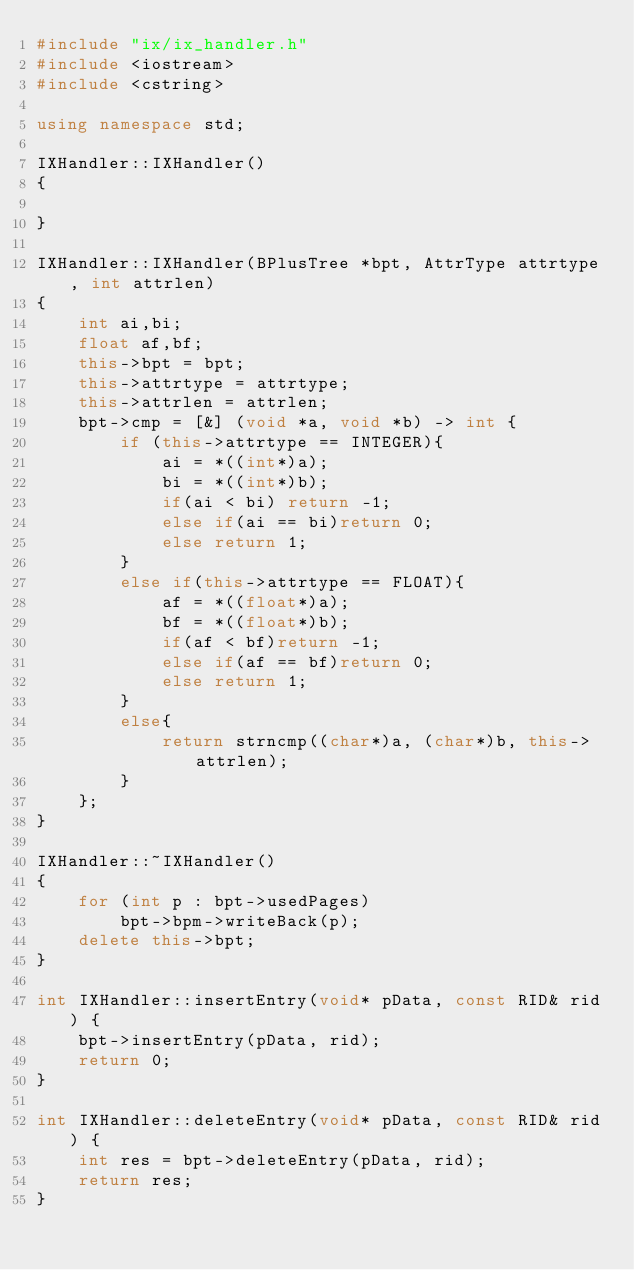<code> <loc_0><loc_0><loc_500><loc_500><_C++_>#include "ix/ix_handler.h"
#include <iostream>
#include <cstring>

using namespace std;

IXHandler::IXHandler()
{

}

IXHandler::IXHandler(BPlusTree *bpt, AttrType attrtype, int attrlen)
{
    int ai,bi;
    float af,bf;
    this->bpt = bpt;
    this->attrtype = attrtype;
    this->attrlen = attrlen;
    bpt->cmp = [&] (void *a, void *b) -> int {
        if (this->attrtype == INTEGER){
            ai = *((int*)a);
            bi = *((int*)b);
            if(ai < bi) return -1;
            else if(ai == bi)return 0;
            else return 1;
        }
        else if(this->attrtype == FLOAT){
            af = *((float*)a);
            bf = *((float*)b);
            if(af < bf)return -1;
            else if(af == bf)return 0;
            else return 1;
        }
        else{
            return strncmp((char*)a, (char*)b, this->attrlen);
        }
    };
}

IXHandler::~IXHandler()
{
    for (int p : bpt->usedPages)
        bpt->bpm->writeBack(p);
    delete this->bpt;
}

int IXHandler::insertEntry(void* pData, const RID& rid) {
    bpt->insertEntry(pData, rid);
    return 0;
}

int IXHandler::deleteEntry(void* pData, const RID& rid) {
    int res = bpt->deleteEntry(pData, rid);
    return res;
}</code> 